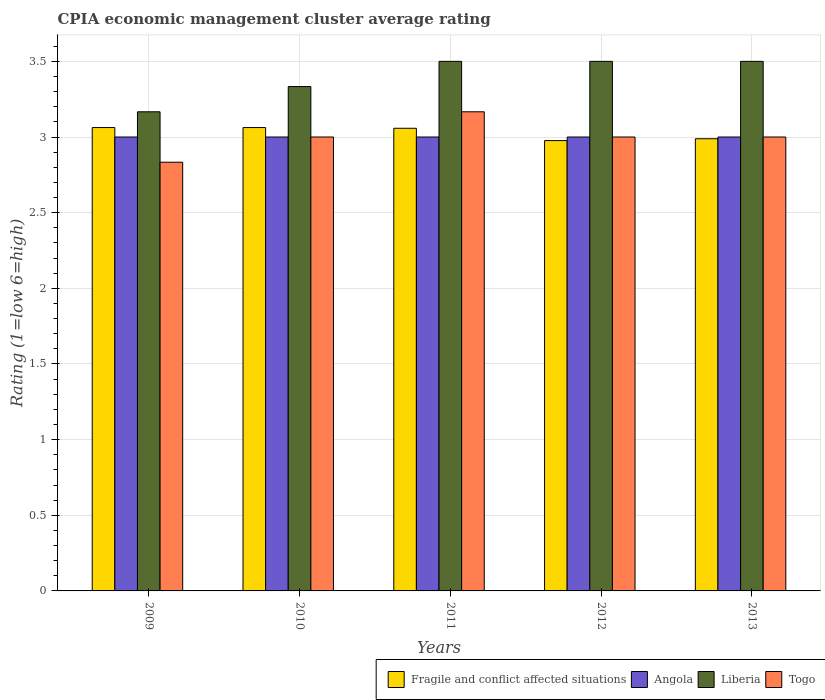How many different coloured bars are there?
Provide a short and direct response. 4. Are the number of bars per tick equal to the number of legend labels?
Your answer should be compact. Yes. Are the number of bars on each tick of the X-axis equal?
Your response must be concise. Yes. What is the label of the 3rd group of bars from the left?
Your answer should be very brief. 2011. In how many cases, is the number of bars for a given year not equal to the number of legend labels?
Offer a terse response. 0. What is the CPIA rating in Fragile and conflict affected situations in 2012?
Keep it short and to the point. 2.98. Across all years, what is the maximum CPIA rating in Liberia?
Ensure brevity in your answer.  3.5. Across all years, what is the minimum CPIA rating in Liberia?
Keep it short and to the point. 3.17. What is the total CPIA rating in Togo in the graph?
Ensure brevity in your answer.  15. What is the difference between the CPIA rating in Fragile and conflict affected situations in 2009 and that in 2012?
Your answer should be compact. 0.09. What is the average CPIA rating in Fragile and conflict affected situations per year?
Provide a short and direct response. 3.03. In the year 2013, what is the difference between the CPIA rating in Angola and CPIA rating in Fragile and conflict affected situations?
Offer a terse response. 0.01. What is the ratio of the CPIA rating in Angola in 2009 to that in 2011?
Provide a short and direct response. 1. Is the CPIA rating in Fragile and conflict affected situations in 2011 less than that in 2013?
Offer a very short reply. No. Is the difference between the CPIA rating in Angola in 2009 and 2011 greater than the difference between the CPIA rating in Fragile and conflict affected situations in 2009 and 2011?
Your response must be concise. No. What is the difference between the highest and the second highest CPIA rating in Fragile and conflict affected situations?
Keep it short and to the point. 0. What is the difference between the highest and the lowest CPIA rating in Liberia?
Make the answer very short. 0.33. In how many years, is the CPIA rating in Liberia greater than the average CPIA rating in Liberia taken over all years?
Provide a short and direct response. 3. What does the 4th bar from the left in 2009 represents?
Offer a very short reply. Togo. What does the 4th bar from the right in 2012 represents?
Your answer should be compact. Fragile and conflict affected situations. How many bars are there?
Your response must be concise. 20. Are the values on the major ticks of Y-axis written in scientific E-notation?
Make the answer very short. No. Does the graph contain grids?
Ensure brevity in your answer.  Yes. How many legend labels are there?
Give a very brief answer. 4. How are the legend labels stacked?
Ensure brevity in your answer.  Horizontal. What is the title of the graph?
Offer a terse response. CPIA economic management cluster average rating. What is the Rating (1=low 6=high) of Fragile and conflict affected situations in 2009?
Your response must be concise. 3.06. What is the Rating (1=low 6=high) of Angola in 2009?
Keep it short and to the point. 3. What is the Rating (1=low 6=high) in Liberia in 2009?
Keep it short and to the point. 3.17. What is the Rating (1=low 6=high) of Togo in 2009?
Ensure brevity in your answer.  2.83. What is the Rating (1=low 6=high) in Fragile and conflict affected situations in 2010?
Ensure brevity in your answer.  3.06. What is the Rating (1=low 6=high) of Angola in 2010?
Offer a very short reply. 3. What is the Rating (1=low 6=high) in Liberia in 2010?
Your response must be concise. 3.33. What is the Rating (1=low 6=high) of Fragile and conflict affected situations in 2011?
Make the answer very short. 3.06. What is the Rating (1=low 6=high) in Angola in 2011?
Your answer should be very brief. 3. What is the Rating (1=low 6=high) of Liberia in 2011?
Provide a short and direct response. 3.5. What is the Rating (1=low 6=high) of Togo in 2011?
Offer a very short reply. 3.17. What is the Rating (1=low 6=high) in Fragile and conflict affected situations in 2012?
Provide a short and direct response. 2.98. What is the Rating (1=low 6=high) in Angola in 2012?
Your answer should be very brief. 3. What is the Rating (1=low 6=high) of Fragile and conflict affected situations in 2013?
Keep it short and to the point. 2.99. What is the Rating (1=low 6=high) in Angola in 2013?
Your answer should be very brief. 3. Across all years, what is the maximum Rating (1=low 6=high) of Fragile and conflict affected situations?
Provide a succinct answer. 3.06. Across all years, what is the maximum Rating (1=low 6=high) of Angola?
Provide a succinct answer. 3. Across all years, what is the maximum Rating (1=low 6=high) of Liberia?
Make the answer very short. 3.5. Across all years, what is the maximum Rating (1=low 6=high) in Togo?
Provide a short and direct response. 3.17. Across all years, what is the minimum Rating (1=low 6=high) of Fragile and conflict affected situations?
Provide a short and direct response. 2.98. Across all years, what is the minimum Rating (1=low 6=high) of Angola?
Make the answer very short. 3. Across all years, what is the minimum Rating (1=low 6=high) of Liberia?
Ensure brevity in your answer.  3.17. Across all years, what is the minimum Rating (1=low 6=high) in Togo?
Make the answer very short. 2.83. What is the total Rating (1=low 6=high) in Fragile and conflict affected situations in the graph?
Offer a terse response. 15.15. What is the total Rating (1=low 6=high) of Angola in the graph?
Offer a very short reply. 15. What is the total Rating (1=low 6=high) in Liberia in the graph?
Your answer should be very brief. 17. What is the total Rating (1=low 6=high) of Togo in the graph?
Make the answer very short. 15. What is the difference between the Rating (1=low 6=high) of Liberia in 2009 and that in 2010?
Offer a very short reply. -0.17. What is the difference between the Rating (1=low 6=high) in Togo in 2009 and that in 2010?
Offer a very short reply. -0.17. What is the difference between the Rating (1=low 6=high) of Fragile and conflict affected situations in 2009 and that in 2011?
Give a very brief answer. 0. What is the difference between the Rating (1=low 6=high) of Angola in 2009 and that in 2011?
Your response must be concise. 0. What is the difference between the Rating (1=low 6=high) of Liberia in 2009 and that in 2011?
Keep it short and to the point. -0.33. What is the difference between the Rating (1=low 6=high) of Fragile and conflict affected situations in 2009 and that in 2012?
Keep it short and to the point. 0.09. What is the difference between the Rating (1=low 6=high) in Fragile and conflict affected situations in 2009 and that in 2013?
Your answer should be compact. 0.07. What is the difference between the Rating (1=low 6=high) of Liberia in 2009 and that in 2013?
Offer a terse response. -0.33. What is the difference between the Rating (1=low 6=high) of Togo in 2009 and that in 2013?
Your response must be concise. -0.17. What is the difference between the Rating (1=low 6=high) in Fragile and conflict affected situations in 2010 and that in 2011?
Provide a short and direct response. 0. What is the difference between the Rating (1=low 6=high) of Angola in 2010 and that in 2011?
Give a very brief answer. 0. What is the difference between the Rating (1=low 6=high) of Fragile and conflict affected situations in 2010 and that in 2012?
Give a very brief answer. 0.09. What is the difference between the Rating (1=low 6=high) in Liberia in 2010 and that in 2012?
Offer a very short reply. -0.17. What is the difference between the Rating (1=low 6=high) of Togo in 2010 and that in 2012?
Offer a very short reply. 0. What is the difference between the Rating (1=low 6=high) of Fragile and conflict affected situations in 2010 and that in 2013?
Provide a short and direct response. 0.07. What is the difference between the Rating (1=low 6=high) in Liberia in 2010 and that in 2013?
Ensure brevity in your answer.  -0.17. What is the difference between the Rating (1=low 6=high) in Fragile and conflict affected situations in 2011 and that in 2012?
Make the answer very short. 0.08. What is the difference between the Rating (1=low 6=high) of Angola in 2011 and that in 2012?
Ensure brevity in your answer.  0. What is the difference between the Rating (1=low 6=high) of Liberia in 2011 and that in 2012?
Provide a succinct answer. 0. What is the difference between the Rating (1=low 6=high) in Togo in 2011 and that in 2012?
Your response must be concise. 0.17. What is the difference between the Rating (1=low 6=high) of Fragile and conflict affected situations in 2011 and that in 2013?
Your answer should be very brief. 0.07. What is the difference between the Rating (1=low 6=high) in Angola in 2011 and that in 2013?
Provide a succinct answer. 0. What is the difference between the Rating (1=low 6=high) of Liberia in 2011 and that in 2013?
Keep it short and to the point. 0. What is the difference between the Rating (1=low 6=high) of Fragile and conflict affected situations in 2012 and that in 2013?
Offer a terse response. -0.01. What is the difference between the Rating (1=low 6=high) in Angola in 2012 and that in 2013?
Your response must be concise. 0. What is the difference between the Rating (1=low 6=high) of Togo in 2012 and that in 2013?
Provide a short and direct response. 0. What is the difference between the Rating (1=low 6=high) of Fragile and conflict affected situations in 2009 and the Rating (1=low 6=high) of Angola in 2010?
Offer a terse response. 0.06. What is the difference between the Rating (1=low 6=high) of Fragile and conflict affected situations in 2009 and the Rating (1=low 6=high) of Liberia in 2010?
Your answer should be compact. -0.27. What is the difference between the Rating (1=low 6=high) in Fragile and conflict affected situations in 2009 and the Rating (1=low 6=high) in Togo in 2010?
Your answer should be compact. 0.06. What is the difference between the Rating (1=low 6=high) of Liberia in 2009 and the Rating (1=low 6=high) of Togo in 2010?
Your response must be concise. 0.17. What is the difference between the Rating (1=low 6=high) of Fragile and conflict affected situations in 2009 and the Rating (1=low 6=high) of Angola in 2011?
Make the answer very short. 0.06. What is the difference between the Rating (1=low 6=high) of Fragile and conflict affected situations in 2009 and the Rating (1=low 6=high) of Liberia in 2011?
Ensure brevity in your answer.  -0.44. What is the difference between the Rating (1=low 6=high) in Fragile and conflict affected situations in 2009 and the Rating (1=low 6=high) in Togo in 2011?
Offer a terse response. -0.1. What is the difference between the Rating (1=low 6=high) of Fragile and conflict affected situations in 2009 and the Rating (1=low 6=high) of Angola in 2012?
Your answer should be very brief. 0.06. What is the difference between the Rating (1=low 6=high) in Fragile and conflict affected situations in 2009 and the Rating (1=low 6=high) in Liberia in 2012?
Ensure brevity in your answer.  -0.44. What is the difference between the Rating (1=low 6=high) of Fragile and conflict affected situations in 2009 and the Rating (1=low 6=high) of Togo in 2012?
Keep it short and to the point. 0.06. What is the difference between the Rating (1=low 6=high) in Angola in 2009 and the Rating (1=low 6=high) in Liberia in 2012?
Your answer should be compact. -0.5. What is the difference between the Rating (1=low 6=high) of Angola in 2009 and the Rating (1=low 6=high) of Togo in 2012?
Give a very brief answer. 0. What is the difference between the Rating (1=low 6=high) of Fragile and conflict affected situations in 2009 and the Rating (1=low 6=high) of Angola in 2013?
Offer a terse response. 0.06. What is the difference between the Rating (1=low 6=high) in Fragile and conflict affected situations in 2009 and the Rating (1=low 6=high) in Liberia in 2013?
Your answer should be very brief. -0.44. What is the difference between the Rating (1=low 6=high) in Fragile and conflict affected situations in 2009 and the Rating (1=low 6=high) in Togo in 2013?
Make the answer very short. 0.06. What is the difference between the Rating (1=low 6=high) of Angola in 2009 and the Rating (1=low 6=high) of Liberia in 2013?
Keep it short and to the point. -0.5. What is the difference between the Rating (1=low 6=high) of Fragile and conflict affected situations in 2010 and the Rating (1=low 6=high) of Angola in 2011?
Your answer should be compact. 0.06. What is the difference between the Rating (1=low 6=high) in Fragile and conflict affected situations in 2010 and the Rating (1=low 6=high) in Liberia in 2011?
Your response must be concise. -0.44. What is the difference between the Rating (1=low 6=high) in Fragile and conflict affected situations in 2010 and the Rating (1=low 6=high) in Togo in 2011?
Make the answer very short. -0.1. What is the difference between the Rating (1=low 6=high) in Angola in 2010 and the Rating (1=low 6=high) in Liberia in 2011?
Offer a terse response. -0.5. What is the difference between the Rating (1=low 6=high) of Fragile and conflict affected situations in 2010 and the Rating (1=low 6=high) of Angola in 2012?
Provide a succinct answer. 0.06. What is the difference between the Rating (1=low 6=high) of Fragile and conflict affected situations in 2010 and the Rating (1=low 6=high) of Liberia in 2012?
Offer a very short reply. -0.44. What is the difference between the Rating (1=low 6=high) of Fragile and conflict affected situations in 2010 and the Rating (1=low 6=high) of Togo in 2012?
Make the answer very short. 0.06. What is the difference between the Rating (1=low 6=high) of Liberia in 2010 and the Rating (1=low 6=high) of Togo in 2012?
Make the answer very short. 0.33. What is the difference between the Rating (1=low 6=high) of Fragile and conflict affected situations in 2010 and the Rating (1=low 6=high) of Angola in 2013?
Offer a terse response. 0.06. What is the difference between the Rating (1=low 6=high) of Fragile and conflict affected situations in 2010 and the Rating (1=low 6=high) of Liberia in 2013?
Keep it short and to the point. -0.44. What is the difference between the Rating (1=low 6=high) of Fragile and conflict affected situations in 2010 and the Rating (1=low 6=high) of Togo in 2013?
Your answer should be very brief. 0.06. What is the difference between the Rating (1=low 6=high) in Fragile and conflict affected situations in 2011 and the Rating (1=low 6=high) in Angola in 2012?
Your answer should be very brief. 0.06. What is the difference between the Rating (1=low 6=high) of Fragile and conflict affected situations in 2011 and the Rating (1=low 6=high) of Liberia in 2012?
Make the answer very short. -0.44. What is the difference between the Rating (1=low 6=high) in Fragile and conflict affected situations in 2011 and the Rating (1=low 6=high) in Togo in 2012?
Provide a short and direct response. 0.06. What is the difference between the Rating (1=low 6=high) in Angola in 2011 and the Rating (1=low 6=high) in Liberia in 2012?
Give a very brief answer. -0.5. What is the difference between the Rating (1=low 6=high) of Fragile and conflict affected situations in 2011 and the Rating (1=low 6=high) of Angola in 2013?
Keep it short and to the point. 0.06. What is the difference between the Rating (1=low 6=high) of Fragile and conflict affected situations in 2011 and the Rating (1=low 6=high) of Liberia in 2013?
Provide a short and direct response. -0.44. What is the difference between the Rating (1=low 6=high) of Fragile and conflict affected situations in 2011 and the Rating (1=low 6=high) of Togo in 2013?
Your answer should be very brief. 0.06. What is the difference between the Rating (1=low 6=high) of Angola in 2011 and the Rating (1=low 6=high) of Togo in 2013?
Provide a short and direct response. 0. What is the difference between the Rating (1=low 6=high) in Fragile and conflict affected situations in 2012 and the Rating (1=low 6=high) in Angola in 2013?
Ensure brevity in your answer.  -0.02. What is the difference between the Rating (1=low 6=high) in Fragile and conflict affected situations in 2012 and the Rating (1=low 6=high) in Liberia in 2013?
Offer a terse response. -0.52. What is the difference between the Rating (1=low 6=high) of Fragile and conflict affected situations in 2012 and the Rating (1=low 6=high) of Togo in 2013?
Ensure brevity in your answer.  -0.02. What is the difference between the Rating (1=low 6=high) of Angola in 2012 and the Rating (1=low 6=high) of Liberia in 2013?
Ensure brevity in your answer.  -0.5. What is the difference between the Rating (1=low 6=high) of Liberia in 2012 and the Rating (1=low 6=high) of Togo in 2013?
Provide a short and direct response. 0.5. What is the average Rating (1=low 6=high) of Fragile and conflict affected situations per year?
Make the answer very short. 3.03. What is the average Rating (1=low 6=high) in Angola per year?
Your response must be concise. 3. What is the average Rating (1=low 6=high) in Liberia per year?
Offer a very short reply. 3.4. In the year 2009, what is the difference between the Rating (1=low 6=high) in Fragile and conflict affected situations and Rating (1=low 6=high) in Angola?
Ensure brevity in your answer.  0.06. In the year 2009, what is the difference between the Rating (1=low 6=high) in Fragile and conflict affected situations and Rating (1=low 6=high) in Liberia?
Offer a terse response. -0.1. In the year 2009, what is the difference between the Rating (1=low 6=high) of Fragile and conflict affected situations and Rating (1=low 6=high) of Togo?
Offer a very short reply. 0.23. In the year 2009, what is the difference between the Rating (1=low 6=high) of Angola and Rating (1=low 6=high) of Liberia?
Your response must be concise. -0.17. In the year 2009, what is the difference between the Rating (1=low 6=high) in Angola and Rating (1=low 6=high) in Togo?
Your response must be concise. 0.17. In the year 2010, what is the difference between the Rating (1=low 6=high) of Fragile and conflict affected situations and Rating (1=low 6=high) of Angola?
Make the answer very short. 0.06. In the year 2010, what is the difference between the Rating (1=low 6=high) of Fragile and conflict affected situations and Rating (1=low 6=high) of Liberia?
Ensure brevity in your answer.  -0.27. In the year 2010, what is the difference between the Rating (1=low 6=high) in Fragile and conflict affected situations and Rating (1=low 6=high) in Togo?
Keep it short and to the point. 0.06. In the year 2010, what is the difference between the Rating (1=low 6=high) of Angola and Rating (1=low 6=high) of Togo?
Keep it short and to the point. 0. In the year 2010, what is the difference between the Rating (1=low 6=high) in Liberia and Rating (1=low 6=high) in Togo?
Provide a succinct answer. 0.33. In the year 2011, what is the difference between the Rating (1=low 6=high) in Fragile and conflict affected situations and Rating (1=low 6=high) in Angola?
Provide a short and direct response. 0.06. In the year 2011, what is the difference between the Rating (1=low 6=high) in Fragile and conflict affected situations and Rating (1=low 6=high) in Liberia?
Provide a succinct answer. -0.44. In the year 2011, what is the difference between the Rating (1=low 6=high) of Fragile and conflict affected situations and Rating (1=low 6=high) of Togo?
Give a very brief answer. -0.11. In the year 2011, what is the difference between the Rating (1=low 6=high) in Liberia and Rating (1=low 6=high) in Togo?
Keep it short and to the point. 0.33. In the year 2012, what is the difference between the Rating (1=low 6=high) of Fragile and conflict affected situations and Rating (1=low 6=high) of Angola?
Ensure brevity in your answer.  -0.02. In the year 2012, what is the difference between the Rating (1=low 6=high) in Fragile and conflict affected situations and Rating (1=low 6=high) in Liberia?
Your answer should be very brief. -0.52. In the year 2012, what is the difference between the Rating (1=low 6=high) in Fragile and conflict affected situations and Rating (1=low 6=high) in Togo?
Offer a very short reply. -0.02. In the year 2012, what is the difference between the Rating (1=low 6=high) in Angola and Rating (1=low 6=high) in Liberia?
Your answer should be very brief. -0.5. In the year 2012, what is the difference between the Rating (1=low 6=high) in Angola and Rating (1=low 6=high) in Togo?
Your answer should be compact. 0. In the year 2013, what is the difference between the Rating (1=low 6=high) of Fragile and conflict affected situations and Rating (1=low 6=high) of Angola?
Give a very brief answer. -0.01. In the year 2013, what is the difference between the Rating (1=low 6=high) of Fragile and conflict affected situations and Rating (1=low 6=high) of Liberia?
Provide a short and direct response. -0.51. In the year 2013, what is the difference between the Rating (1=low 6=high) of Fragile and conflict affected situations and Rating (1=low 6=high) of Togo?
Offer a terse response. -0.01. In the year 2013, what is the difference between the Rating (1=low 6=high) in Angola and Rating (1=low 6=high) in Liberia?
Offer a very short reply. -0.5. What is the ratio of the Rating (1=low 6=high) in Fragile and conflict affected situations in 2009 to that in 2010?
Offer a very short reply. 1. What is the ratio of the Rating (1=low 6=high) of Angola in 2009 to that in 2010?
Your response must be concise. 1. What is the ratio of the Rating (1=low 6=high) of Liberia in 2009 to that in 2011?
Your response must be concise. 0.9. What is the ratio of the Rating (1=low 6=high) in Togo in 2009 to that in 2011?
Your answer should be very brief. 0.89. What is the ratio of the Rating (1=low 6=high) in Liberia in 2009 to that in 2012?
Your answer should be compact. 0.9. What is the ratio of the Rating (1=low 6=high) in Togo in 2009 to that in 2012?
Provide a short and direct response. 0.94. What is the ratio of the Rating (1=low 6=high) in Fragile and conflict affected situations in 2009 to that in 2013?
Keep it short and to the point. 1.02. What is the ratio of the Rating (1=low 6=high) in Liberia in 2009 to that in 2013?
Keep it short and to the point. 0.9. What is the ratio of the Rating (1=low 6=high) of Angola in 2010 to that in 2011?
Your answer should be compact. 1. What is the ratio of the Rating (1=low 6=high) in Liberia in 2010 to that in 2011?
Your response must be concise. 0.95. What is the ratio of the Rating (1=low 6=high) in Togo in 2010 to that in 2011?
Keep it short and to the point. 0.95. What is the ratio of the Rating (1=low 6=high) in Fragile and conflict affected situations in 2010 to that in 2012?
Make the answer very short. 1.03. What is the ratio of the Rating (1=low 6=high) in Angola in 2010 to that in 2012?
Ensure brevity in your answer.  1. What is the ratio of the Rating (1=low 6=high) of Togo in 2010 to that in 2012?
Provide a short and direct response. 1. What is the ratio of the Rating (1=low 6=high) of Fragile and conflict affected situations in 2010 to that in 2013?
Keep it short and to the point. 1.02. What is the ratio of the Rating (1=low 6=high) of Angola in 2010 to that in 2013?
Offer a very short reply. 1. What is the ratio of the Rating (1=low 6=high) in Liberia in 2010 to that in 2013?
Provide a succinct answer. 0.95. What is the ratio of the Rating (1=low 6=high) of Fragile and conflict affected situations in 2011 to that in 2012?
Give a very brief answer. 1.03. What is the ratio of the Rating (1=low 6=high) in Angola in 2011 to that in 2012?
Give a very brief answer. 1. What is the ratio of the Rating (1=low 6=high) of Togo in 2011 to that in 2012?
Provide a succinct answer. 1.06. What is the ratio of the Rating (1=low 6=high) in Fragile and conflict affected situations in 2011 to that in 2013?
Make the answer very short. 1.02. What is the ratio of the Rating (1=low 6=high) in Liberia in 2011 to that in 2013?
Your answer should be compact. 1. What is the ratio of the Rating (1=low 6=high) of Togo in 2011 to that in 2013?
Keep it short and to the point. 1.06. What is the ratio of the Rating (1=low 6=high) of Fragile and conflict affected situations in 2012 to that in 2013?
Ensure brevity in your answer.  1. What is the ratio of the Rating (1=low 6=high) in Liberia in 2012 to that in 2013?
Keep it short and to the point. 1. What is the ratio of the Rating (1=low 6=high) in Togo in 2012 to that in 2013?
Offer a very short reply. 1. What is the difference between the highest and the second highest Rating (1=low 6=high) of Fragile and conflict affected situations?
Provide a succinct answer. 0. What is the difference between the highest and the second highest Rating (1=low 6=high) of Angola?
Provide a succinct answer. 0. What is the difference between the highest and the lowest Rating (1=low 6=high) in Fragile and conflict affected situations?
Offer a terse response. 0.09. What is the difference between the highest and the lowest Rating (1=low 6=high) of Angola?
Provide a succinct answer. 0. 